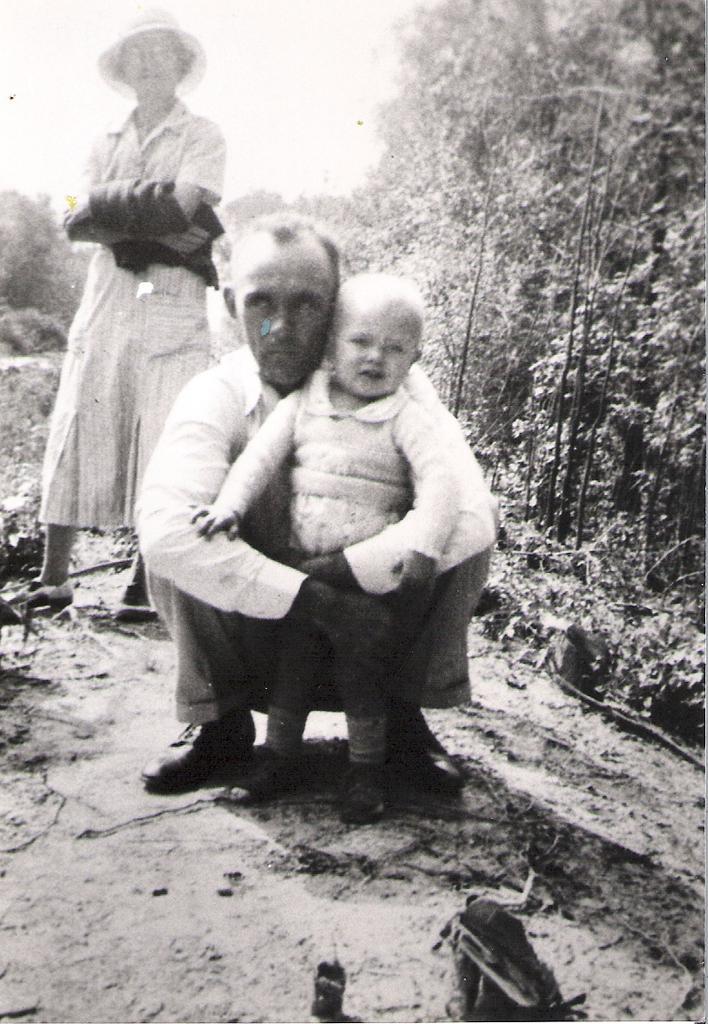Please provide a concise description of this image. In this picture we can see people and in the background we can see trees. 